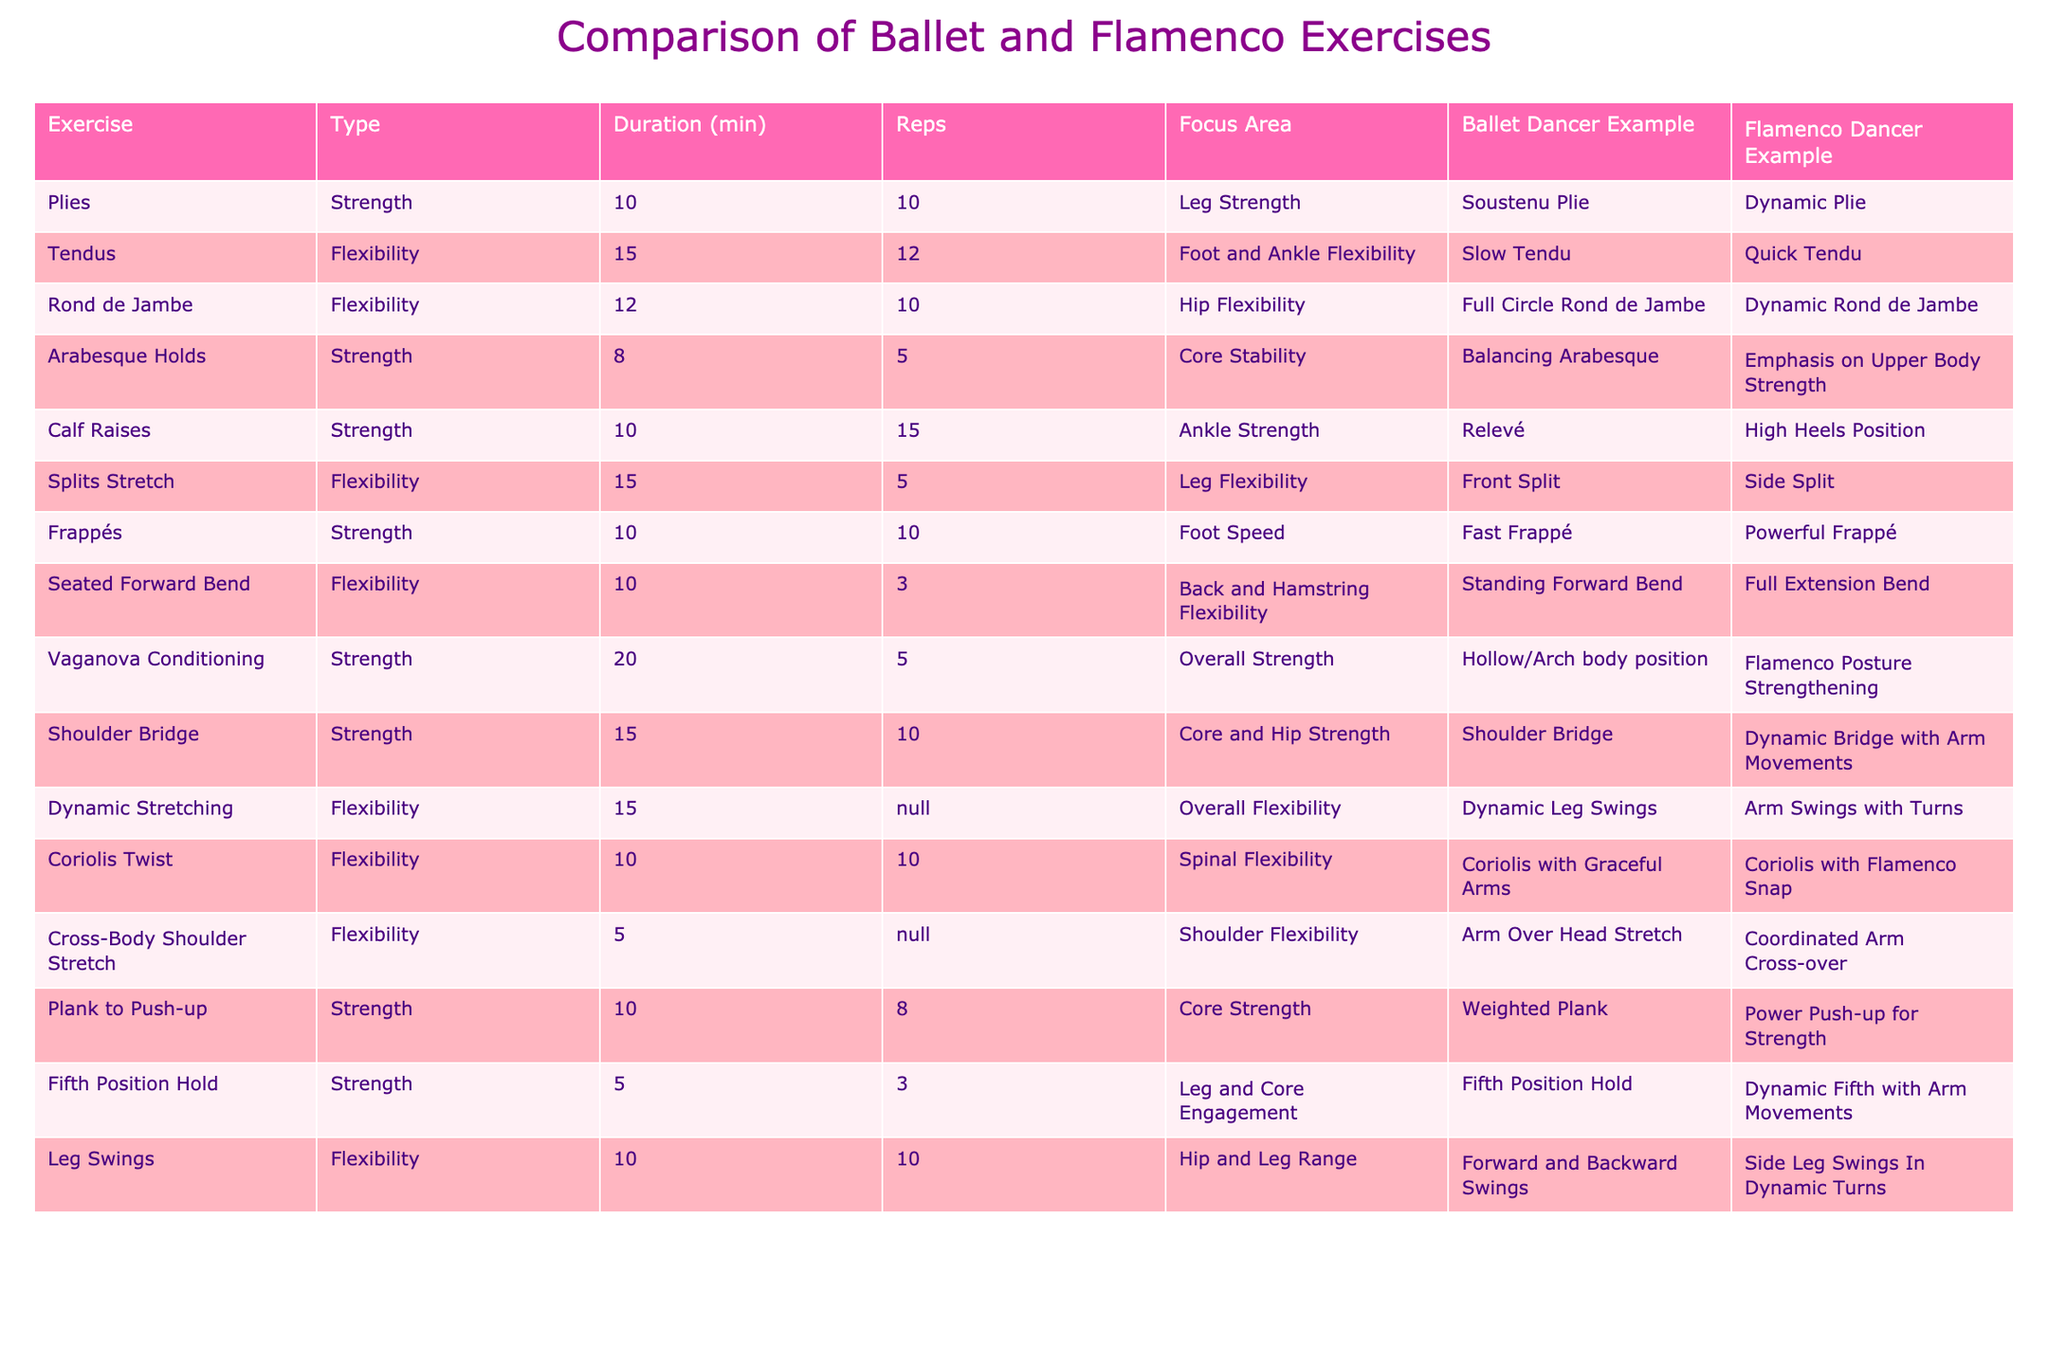What is the duration of the exercise "Frappés"? According to the table, the duration listed for "Frappés" is 10 minutes.
Answer: 10 minutes Which type of exercise focuses on core stability? The exercise focusing on core stability is "Arabesque Holds," as indicated in the table under the Focus Area column.
Answer: Arabesque Holds What is the total duration of strength exercises listed in the table? The strength exercises and their durations are: Plies (10 min) + Arabesque Holds (8 min) + Calf Raises (10 min) + Frappés (10 min) + Vaganova Conditioning (20 min) + Shoulder Bridge (15 min) + Plank to Push-up (10 min) + Fifth Position Hold (5 min) = 88 minutes total.
Answer: 88 minutes How many repetitions are suggested for "Tendus"? The table states that "Tendus" should be done for 12 repetitions.
Answer: 12 repetitions Is "Calf Raises" a flexibility exercise? No, "Calf Raises" is categorized as a strength exercise according to the table.
Answer: No Which exercise has the highest duration and what is it? The exercise with the highest duration is "Vaganova Conditioning," with a duration of 20 minutes.
Answer: Vaganova Conditioning What is the average duration of flexibility exercises listed? The flexibility exercises are Tendus (15 min) + Rond de Jambe (12 min) + Splits Stretch (15 min) + Seated Forward Bend (10 min) + Dynamic Stretching (15 min) + Coriolis Twist (10 min) + Cross-Body Shoulder Stretch (5 min) + Leg Swings (10 min). The total duration is 97 minutes and there are 8 flexibility exercises, resulting in an average of 97 / 8 = 12.125 minutes.
Answer: 12.125 minutes Which flamenco dancer example emphasizes upper body strength? The flamenco dancer example that emphasizes upper body strength is "Emphasis on Upper Body Strength" from the "Arabesque Holds" exercise.
Answer: Emphasis on Upper Body Strength Are there any exercises that last only 5 minutes? Yes, both "Fifth Position Hold" and "Cross-Body Shoulder Stretch" last 5 minutes each.
Answer: Yes How many strength exercises are listed in total? The strength exercises listed in the table are: Plies, Arabesque Holds, Calf Raises, Frappés, Vaganova Conditioning, Shoulder Bridge, Plank to Push-up, and Fifth Position Hold, totaling 8 strength exercises.
Answer: 8 